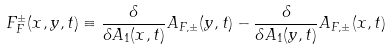Convert formula to latex. <formula><loc_0><loc_0><loc_500><loc_500>F _ { F } ^ { \pm } ( x , y , t ) \equiv \frac { \delta } { \delta A _ { 1 } ( x , t ) } A _ { F , \pm } ( y , t ) - \frac { \delta } { \delta A _ { 1 } ( y , t ) } A _ { F , \pm } ( x , t )</formula> 